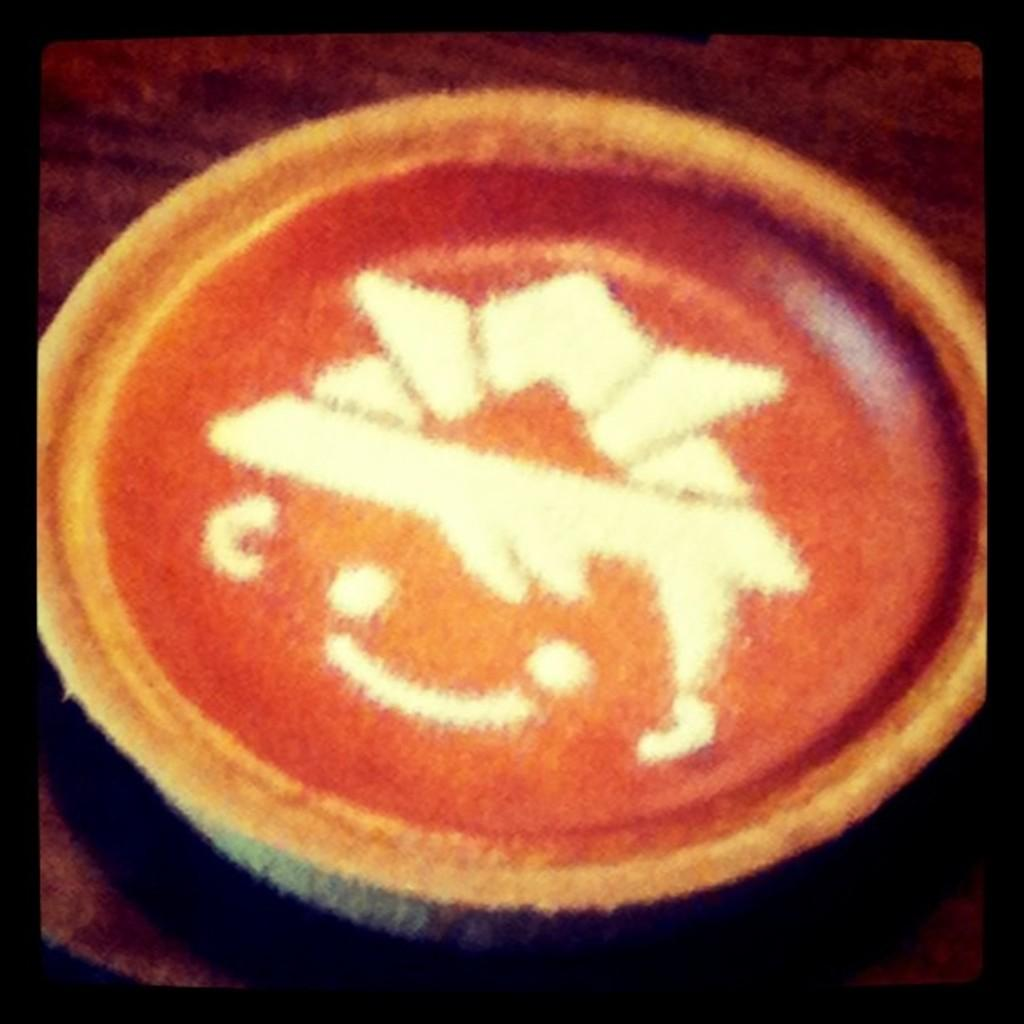What is the main object in the image? There is a coffee cup in the image. Where is the coffee cup placed? The coffee cup is placed on a brown table. What can be seen on the coffee cup? There is a white color design on the coffee. What date is circled on the calendar in the image? There is no calendar present in the image; it only features a coffee cup on a brown table with a white design on the coffee. 